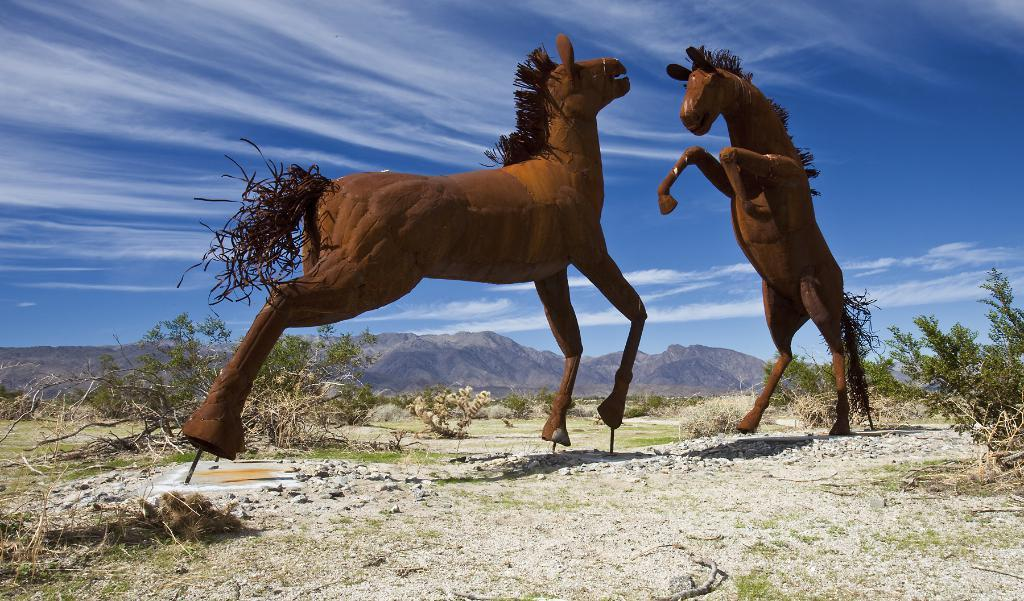What type of statues can be seen on the ground in the image? There are horse statues on the ground in the image. What type of vegetation is visible in the image? There is grass and plants visible in the image. What can be seen in the background of the image? Mountains and the sky are visible in the background of the image. What type of crime is being committed by the dolls in the image? There are no dolls present in the image, so it is not possible to determine if any crime is being committed. 